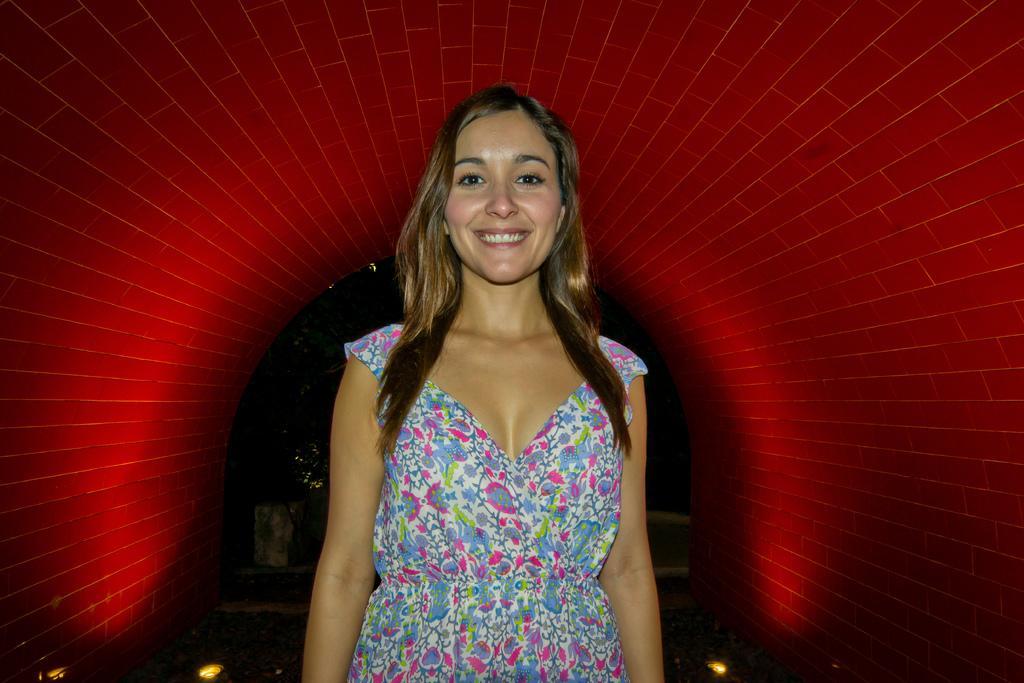How would you summarize this image in a sentence or two? In this image we can see a woman. On the backside we can see a wall. 